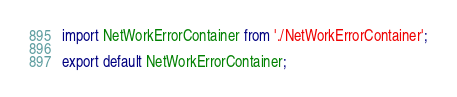Convert code to text. <code><loc_0><loc_0><loc_500><loc_500><_JavaScript_>import NetWorkErrorContainer from './NetWorkErrorContainer';

export default NetWorkErrorContainer;</code> 